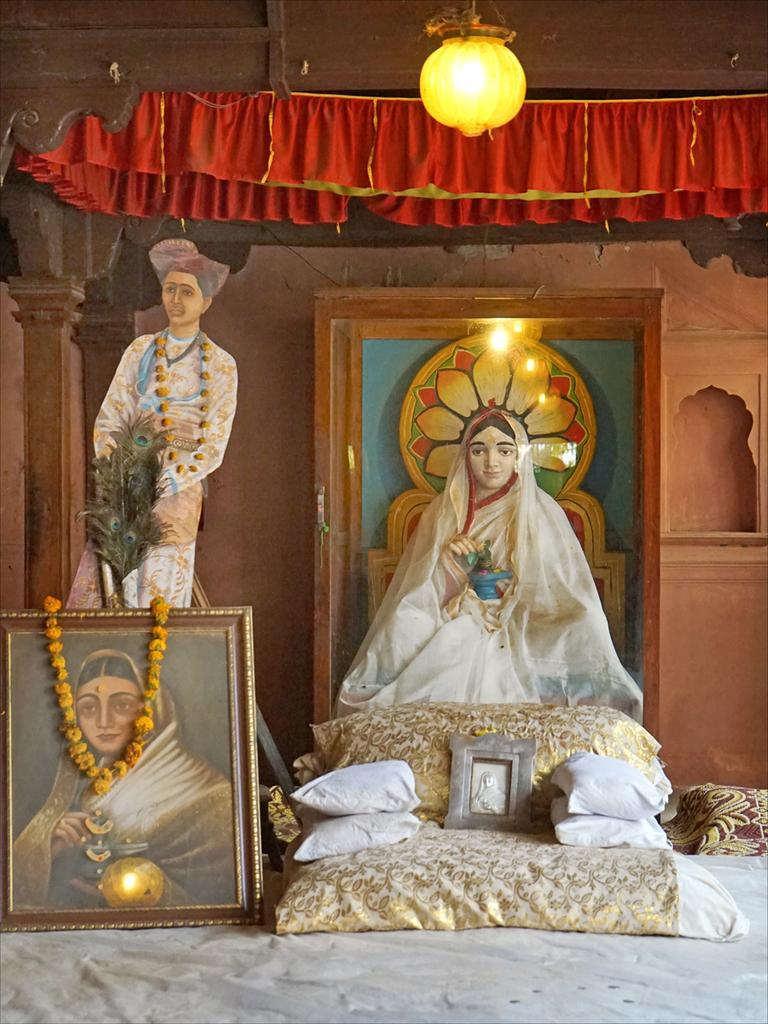In one or two sentences, can you explain what this image depicts? In the center of the image we can see one bed. On the bed, we can see pillows, photo frames, flower garland, sculpture and a few other objects. In the background there is a wooden wall, light, curtains, poles and a few other objects. 